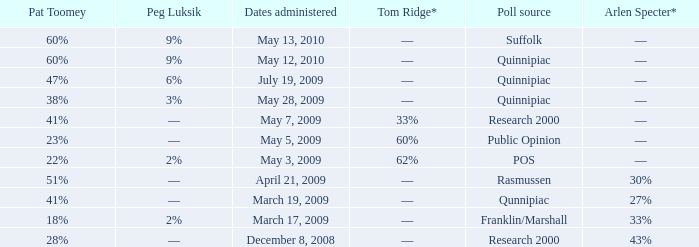Help me parse the entirety of this table. {'header': ['Pat Toomey', 'Peg Luksik', 'Dates administered', 'Tom Ridge*', 'Poll source', 'Arlen Specter*'], 'rows': [['60%', '9%', 'May 13, 2010', '––', 'Suffolk', '––'], ['60%', '9%', 'May 12, 2010', '––', 'Quinnipiac', '––'], ['47%', '6%', 'July 19, 2009', '––', 'Quinnipiac', '––'], ['38%', '3%', 'May 28, 2009', '––', 'Quinnipiac', '––'], ['41%', '––', 'May 7, 2009', '33%', 'Research 2000', '––'], ['23%', '––', 'May 5, 2009', '60%', 'Public Opinion', '––'], ['22%', '2%', 'May 3, 2009', '62%', 'POS', '––'], ['51%', '––', 'April 21, 2009', '––', 'Rasmussen', '30%'], ['41%', '––', 'March 19, 2009', '––', 'Qunnipiac', '27%'], ['18%', '2%', 'March 17, 2009', '––', 'Franklin/Marshall', '33%'], ['28%', '––', 'December 8, 2008', '––', 'Research 2000', '43%']]} Which Poll source has Pat Toomey of 23%? Public Opinion. 